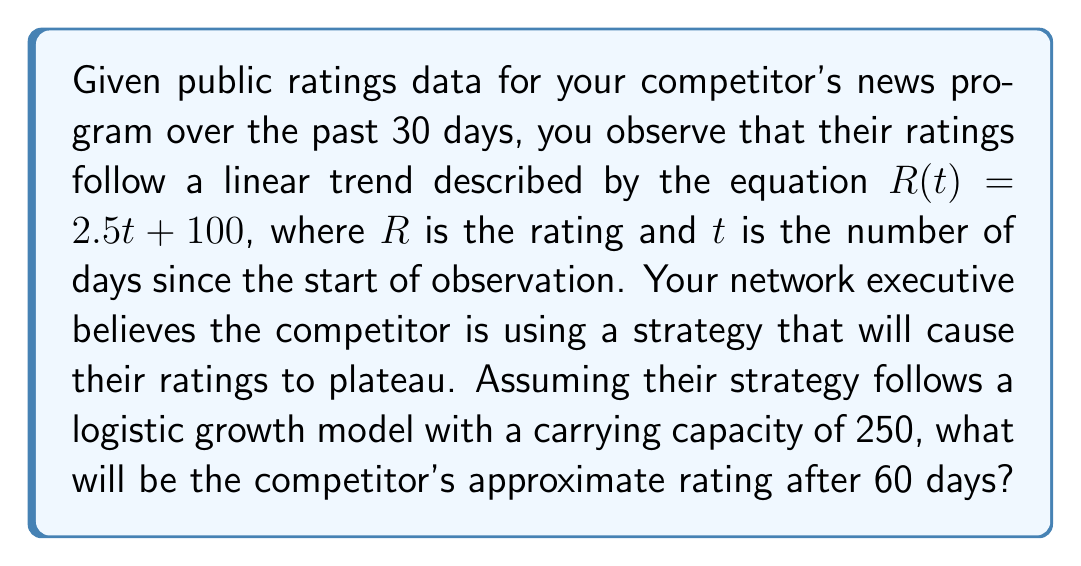Help me with this question. To solve this problem, we need to combine the linear trend with a logistic growth model:

1) The linear trend is given by $R(t) = 2.5t + 100$

2) The logistic growth model is described by the differential equation:
   $$\frac{dR}{dt} = k R (1 - \frac{R}{K})$$
   where $k$ is the growth rate and $K$ is the carrying capacity (250 in this case)

3) We need to find $k$. At $t=0$, $R=100$ and $\frac{dR}{dt}=2.5$ (from the linear trend)
   Substituting into the logistic equation:
   $$2.5 = k \cdot 100 \cdot (1 - \frac{100}{250})$$
   $$2.5 = 60k$$
   $$k = \frac{1}{24}$$

4) Now we have the full logistic equation:
   $$\frac{dR}{dt} = \frac{1}{24} R (1 - \frac{R}{250})$$

5) The solution to this equation is:
   $$R(t) = \frac{250}{1 + (\frac{250}{100} - 1)e^{-\frac{t}{24}}}$$

6) Evaluating at $t=60$:
   $$R(60) = \frac{250}{1 + 1.5e^{-2.5}} \approx 212.8$$

Therefore, after 60 days, the competitor's rating will be approximately 213.
Answer: 213 